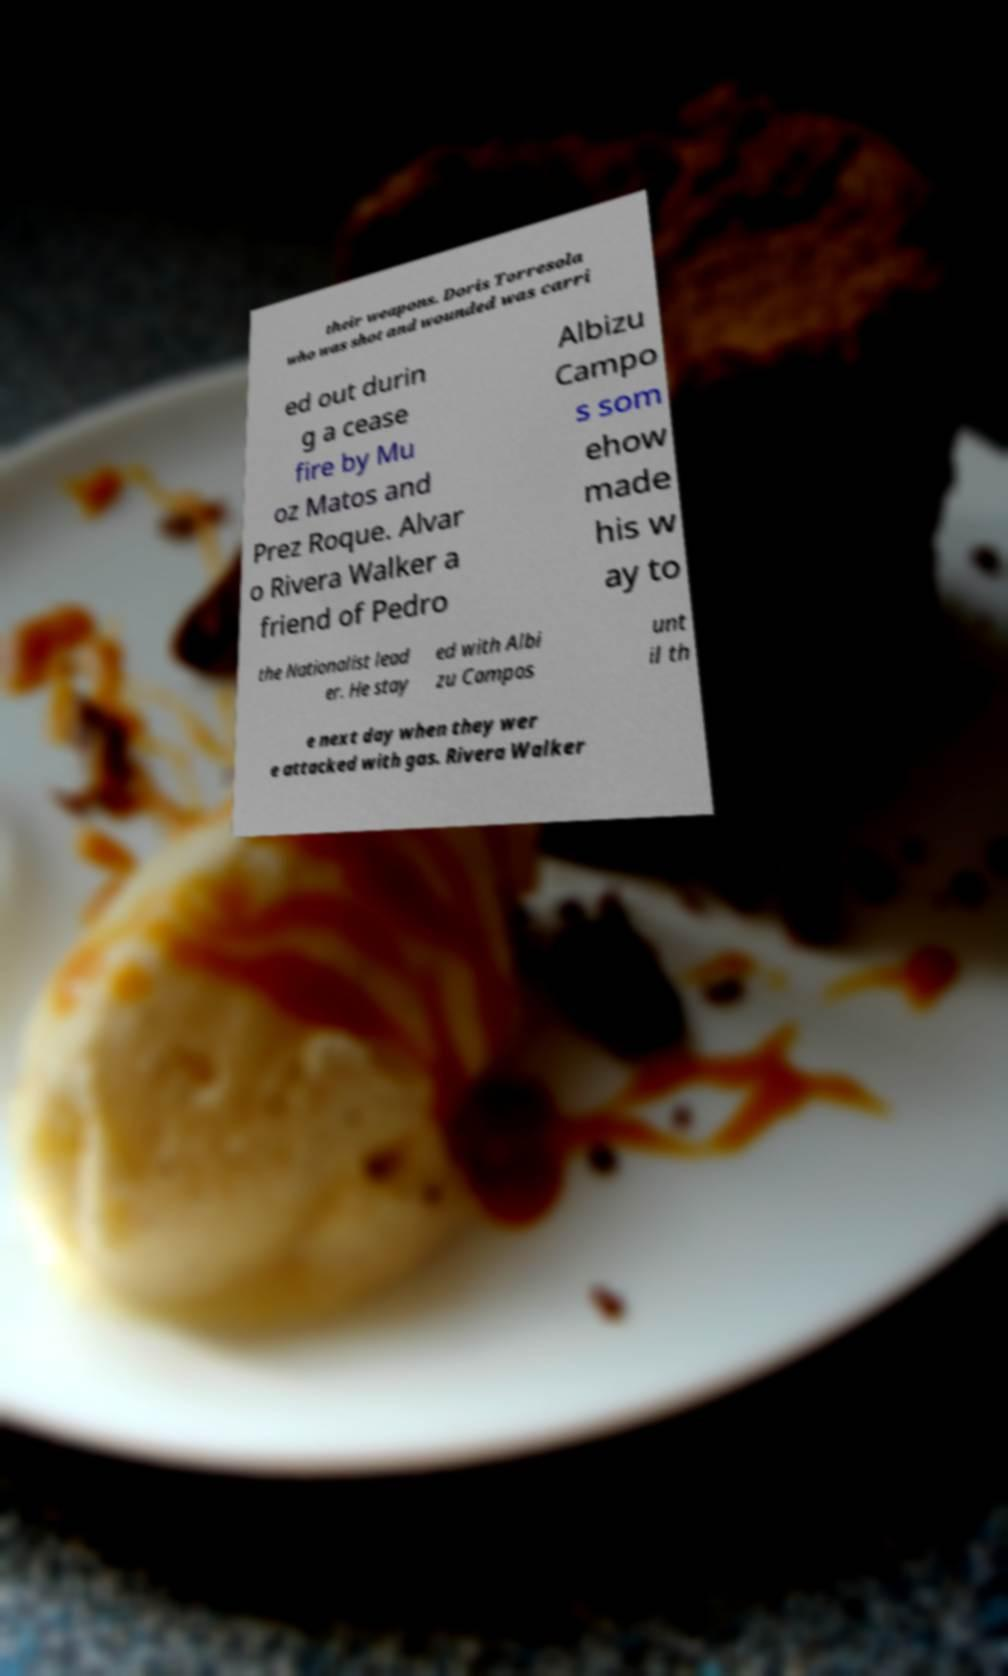I need the written content from this picture converted into text. Can you do that? their weapons. Doris Torresola who was shot and wounded was carri ed out durin g a cease fire by Mu oz Matos and Prez Roque. Alvar o Rivera Walker a friend of Pedro Albizu Campo s som ehow made his w ay to the Nationalist lead er. He stay ed with Albi zu Campos unt il th e next day when they wer e attacked with gas. Rivera Walker 